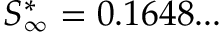Convert formula to latex. <formula><loc_0><loc_0><loc_500><loc_500>S _ { \infty } ^ { * } = 0 . 1 6 4 8 \dots</formula> 